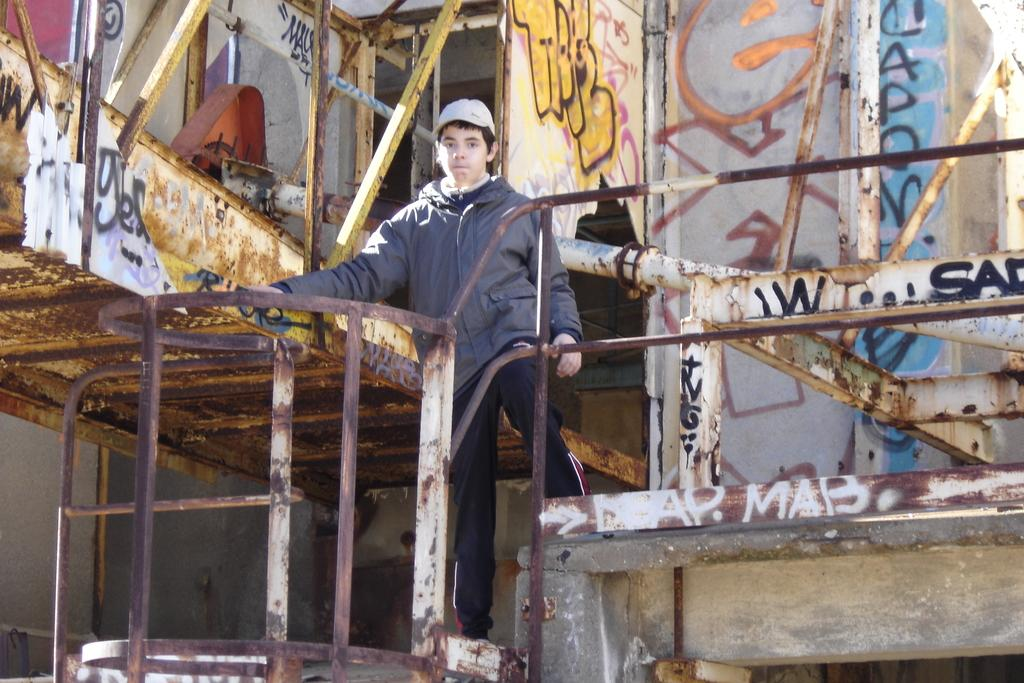Who is the main subject in the image? There is a boy in the image. What is the boy wearing? The boy is wearing a jacket and a cap. What type of fence is visible in the image? There is a metal block fence in the image. What can be seen on the wall in the image? There is graffiti on a wall in the image. How does the boy guide the hole in the image? There is no hole present in the image, and therefore the boy is not guiding any hole. 